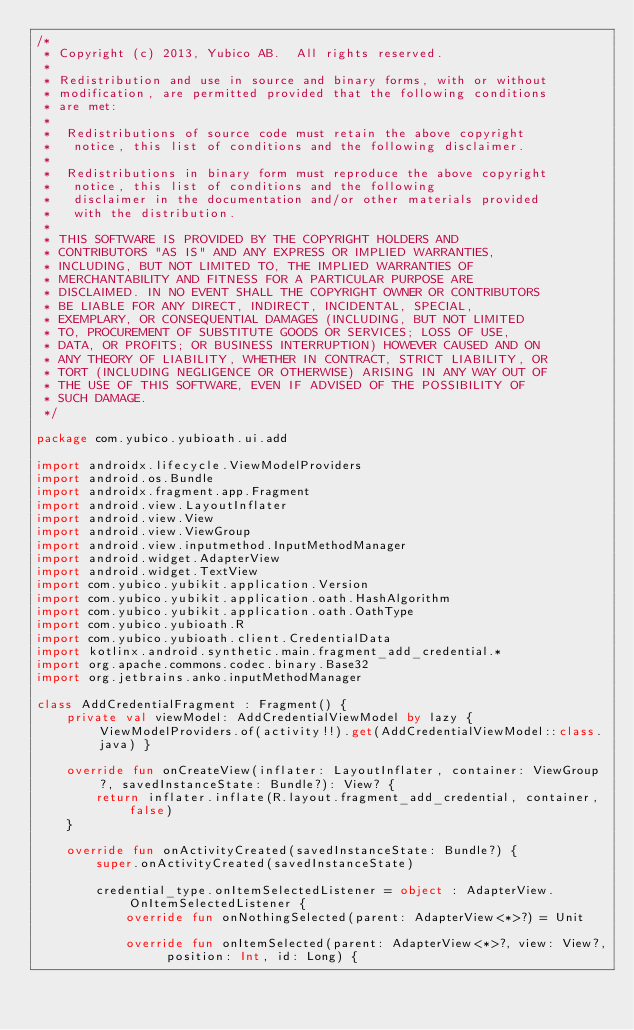<code> <loc_0><loc_0><loc_500><loc_500><_Kotlin_>/*
 * Copyright (c) 2013, Yubico AB.  All rights reserved.
 *
 * Redistribution and use in source and binary forms, with or without
 * modification, are permitted provided that the following conditions
 * are met:
 *
 *  Redistributions of source code must retain the above copyright
 *   notice, this list of conditions and the following disclaimer.
 *
 *  Redistributions in binary form must reproduce the above copyright
 *   notice, this list of conditions and the following
 *   disclaimer in the documentation and/or other materials provided
 *   with the distribution.
 *
 * THIS SOFTWARE IS PROVIDED BY THE COPYRIGHT HOLDERS AND
 * CONTRIBUTORS "AS IS" AND ANY EXPRESS OR IMPLIED WARRANTIES,
 * INCLUDING, BUT NOT LIMITED TO, THE IMPLIED WARRANTIES OF
 * MERCHANTABILITY AND FITNESS FOR A PARTICULAR PURPOSE ARE
 * DISCLAIMED. IN NO EVENT SHALL THE COPYRIGHT OWNER OR CONTRIBUTORS
 * BE LIABLE FOR ANY DIRECT, INDIRECT, INCIDENTAL, SPECIAL,
 * EXEMPLARY, OR CONSEQUENTIAL DAMAGES (INCLUDING, BUT NOT LIMITED
 * TO, PROCUREMENT OF SUBSTITUTE GOODS OR SERVICES; LOSS OF USE,
 * DATA, OR PROFITS; OR BUSINESS INTERRUPTION) HOWEVER CAUSED AND ON
 * ANY THEORY OF LIABILITY, WHETHER IN CONTRACT, STRICT LIABILITY, OR
 * TORT (INCLUDING NEGLIGENCE OR OTHERWISE) ARISING IN ANY WAY OUT OF
 * THE USE OF THIS SOFTWARE, EVEN IF ADVISED OF THE POSSIBILITY OF
 * SUCH DAMAGE.
 */

package com.yubico.yubioath.ui.add

import androidx.lifecycle.ViewModelProviders
import android.os.Bundle
import androidx.fragment.app.Fragment
import android.view.LayoutInflater
import android.view.View
import android.view.ViewGroup
import android.view.inputmethod.InputMethodManager
import android.widget.AdapterView
import android.widget.TextView
import com.yubico.yubikit.application.Version
import com.yubico.yubikit.application.oath.HashAlgorithm
import com.yubico.yubikit.application.oath.OathType
import com.yubico.yubioath.R
import com.yubico.yubioath.client.CredentialData
import kotlinx.android.synthetic.main.fragment_add_credential.*
import org.apache.commons.codec.binary.Base32
import org.jetbrains.anko.inputMethodManager

class AddCredentialFragment : Fragment() {
    private val viewModel: AddCredentialViewModel by lazy { ViewModelProviders.of(activity!!).get(AddCredentialViewModel::class.java) }

    override fun onCreateView(inflater: LayoutInflater, container: ViewGroup?, savedInstanceState: Bundle?): View? {
        return inflater.inflate(R.layout.fragment_add_credential, container, false)
    }

    override fun onActivityCreated(savedInstanceState: Bundle?) {
        super.onActivityCreated(savedInstanceState)

        credential_type.onItemSelectedListener = object : AdapterView.OnItemSelectedListener {
            override fun onNothingSelected(parent: AdapterView<*>?) = Unit

            override fun onItemSelected(parent: AdapterView<*>?, view: View?, position: Int, id: Long) {</code> 